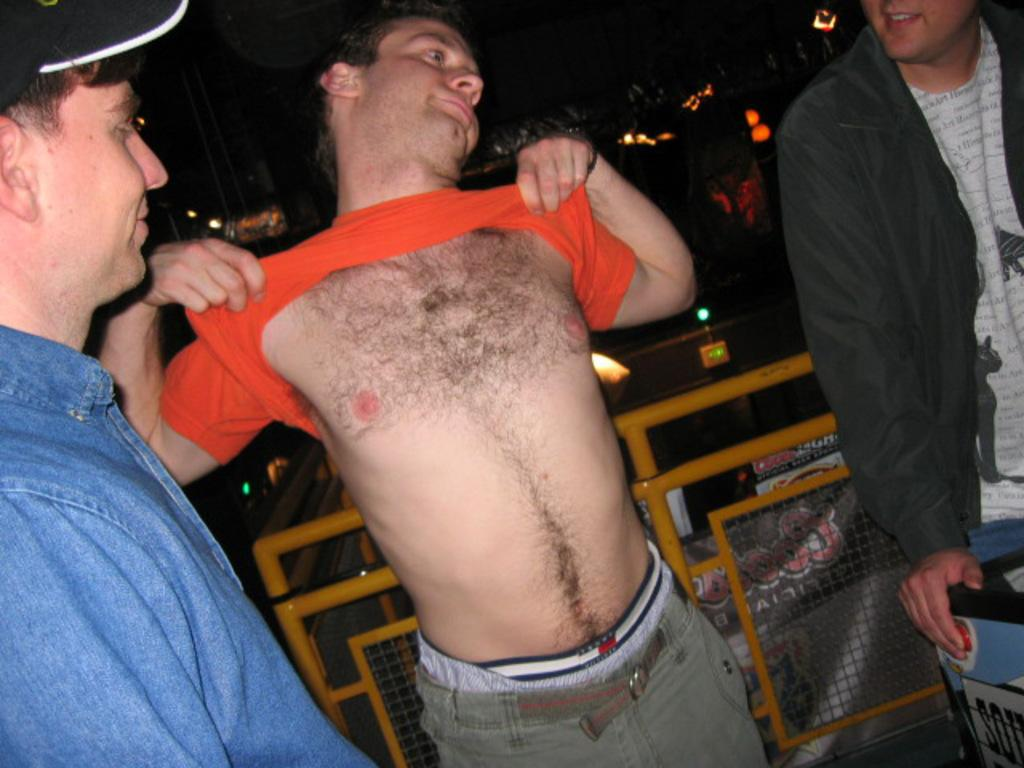How many men are present in the image? There are three men standing in the image. What can be seen in the background of the image? There is a metal fence, poles, and lights visible in the background. Can you describe the hand of a person in the image? There is a hand of a person on an object on the right side of the image. What type of spade is being used by the person in the image? There is no spade present in the image. Is the person wearing a mitten in the image? There is no mention of a mitten or any gloves in the image. 